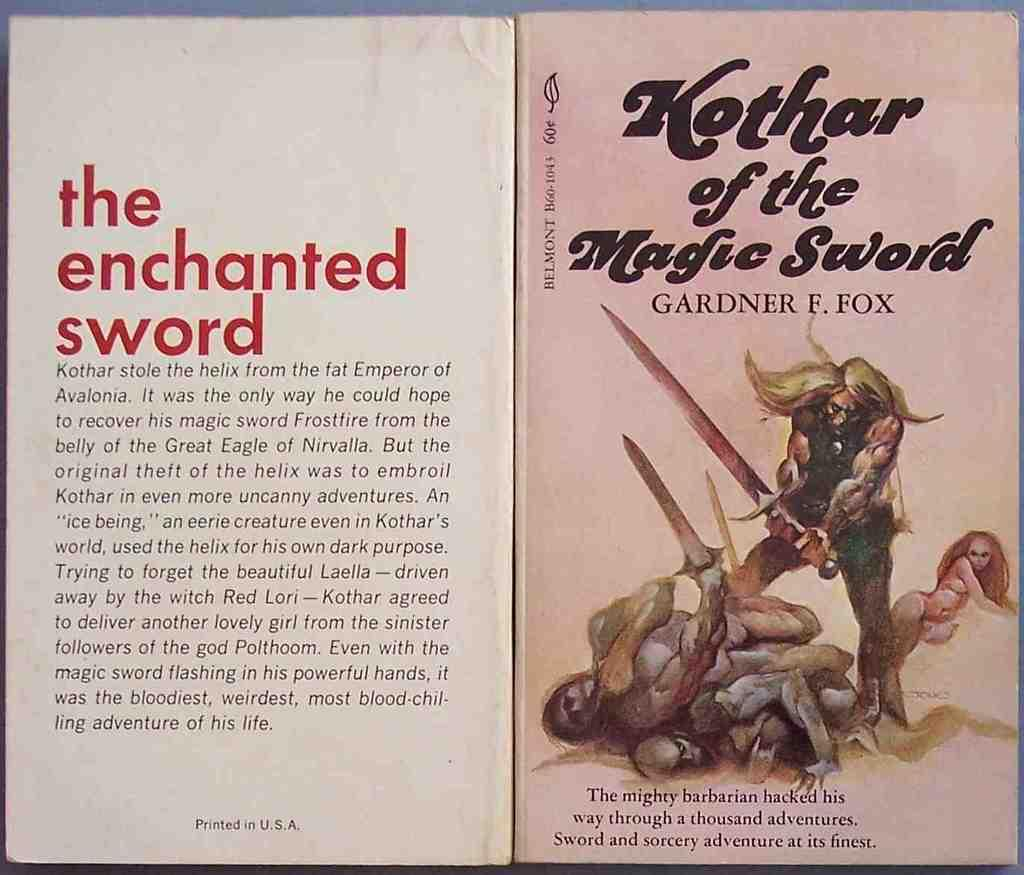What is the main subject in the center of the image? There is a poster in the center of the image. What are the people on the poster doing? The people on the poster are holding a sword. Is there any text on the poster? Yes, there is writing on the poster. What type of behavior is being exhibited by the nation in the image? There is no nation present in the image, only a poster with people holding a sword and writing. How many rooms can be seen in the image? There are no rooms visible in the image; it features a poster with people holding a sword and writing. 